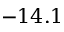<formula> <loc_0><loc_0><loc_500><loc_500>- 1 4 . 1</formula> 